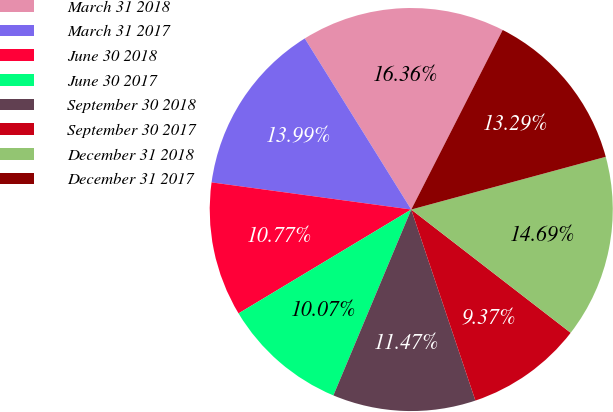<chart> <loc_0><loc_0><loc_500><loc_500><pie_chart><fcel>March 31 2018<fcel>March 31 2017<fcel>June 30 2018<fcel>June 30 2017<fcel>September 30 2018<fcel>September 30 2017<fcel>December 31 2018<fcel>December 31 2017<nl><fcel>16.36%<fcel>13.99%<fcel>10.77%<fcel>10.07%<fcel>11.47%<fcel>9.37%<fcel>14.69%<fcel>13.29%<nl></chart> 